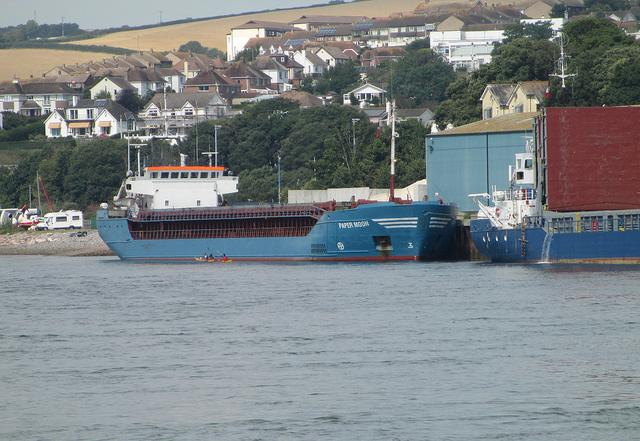What might live in this environment?

Choices:
A) fish
B) birds
C) worms
D) cats fish 